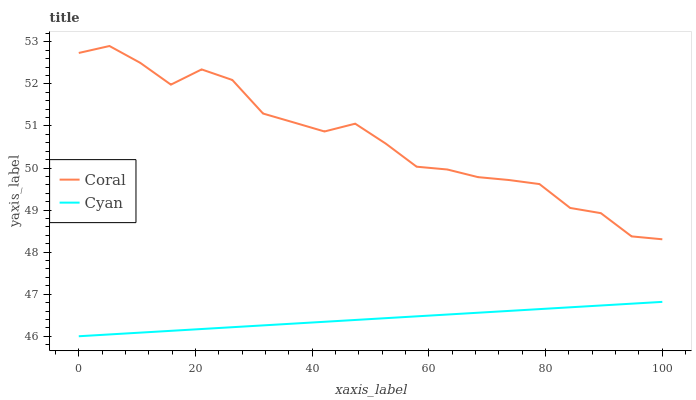Does Cyan have the minimum area under the curve?
Answer yes or no. Yes. Does Coral have the maximum area under the curve?
Answer yes or no. Yes. Does Coral have the minimum area under the curve?
Answer yes or no. No. Is Cyan the smoothest?
Answer yes or no. Yes. Is Coral the roughest?
Answer yes or no. Yes. Is Coral the smoothest?
Answer yes or no. No. Does Cyan have the lowest value?
Answer yes or no. Yes. Does Coral have the lowest value?
Answer yes or no. No. Does Coral have the highest value?
Answer yes or no. Yes. Is Cyan less than Coral?
Answer yes or no. Yes. Is Coral greater than Cyan?
Answer yes or no. Yes. Does Cyan intersect Coral?
Answer yes or no. No. 